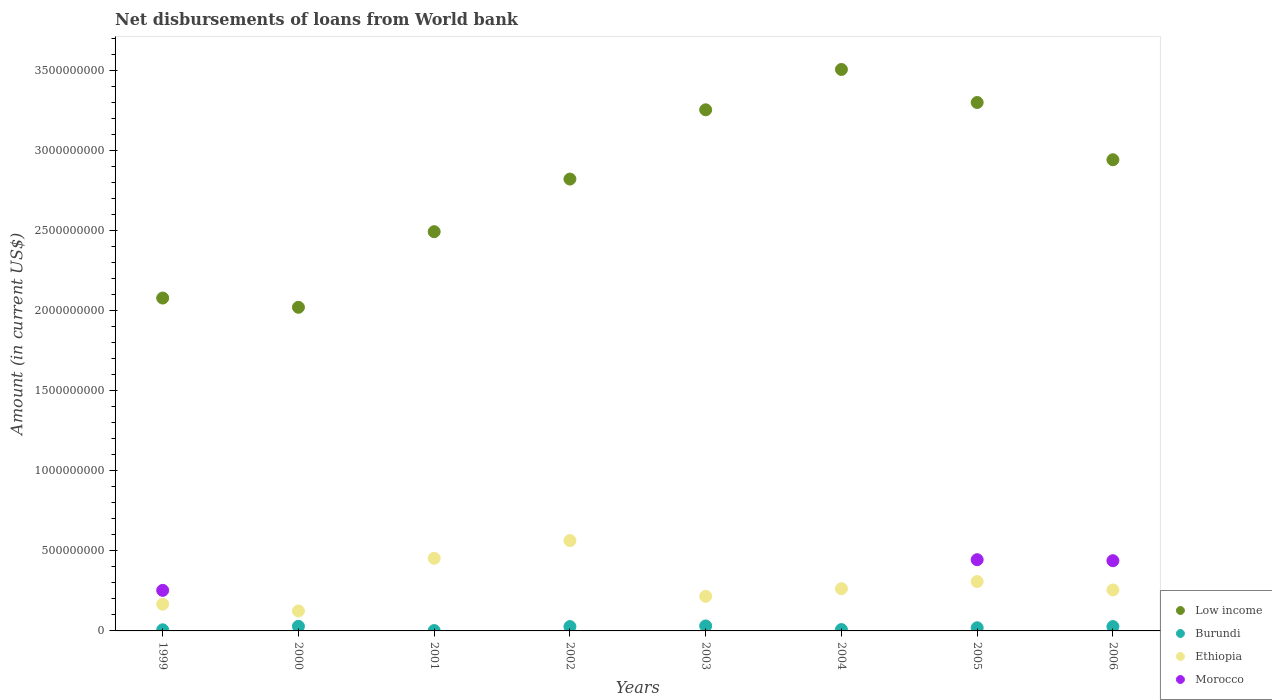How many different coloured dotlines are there?
Keep it short and to the point. 4. What is the amount of loan disbursed from World Bank in Burundi in 2003?
Your response must be concise. 3.12e+07. Across all years, what is the maximum amount of loan disbursed from World Bank in Morocco?
Your answer should be compact. 4.45e+08. Across all years, what is the minimum amount of loan disbursed from World Bank in Burundi?
Keep it short and to the point. 2.28e+06. In which year was the amount of loan disbursed from World Bank in Morocco maximum?
Make the answer very short. 2005. What is the total amount of loan disbursed from World Bank in Morocco in the graph?
Provide a short and direct response. 1.14e+09. What is the difference between the amount of loan disbursed from World Bank in Burundi in 2001 and that in 2004?
Give a very brief answer. -6.18e+06. What is the difference between the amount of loan disbursed from World Bank in Morocco in 2004 and the amount of loan disbursed from World Bank in Low income in 2003?
Provide a short and direct response. -3.26e+09. What is the average amount of loan disbursed from World Bank in Morocco per year?
Keep it short and to the point. 1.42e+08. In the year 2005, what is the difference between the amount of loan disbursed from World Bank in Ethiopia and amount of loan disbursed from World Bank in Low income?
Provide a short and direct response. -2.99e+09. In how many years, is the amount of loan disbursed from World Bank in Ethiopia greater than 1800000000 US$?
Keep it short and to the point. 0. What is the ratio of the amount of loan disbursed from World Bank in Burundi in 2003 to that in 2006?
Your answer should be compact. 1.15. Is the difference between the amount of loan disbursed from World Bank in Ethiopia in 2004 and 2006 greater than the difference between the amount of loan disbursed from World Bank in Low income in 2004 and 2006?
Provide a short and direct response. No. What is the difference between the highest and the second highest amount of loan disbursed from World Bank in Low income?
Provide a short and direct response. 2.06e+08. What is the difference between the highest and the lowest amount of loan disbursed from World Bank in Morocco?
Give a very brief answer. 4.45e+08. In how many years, is the amount of loan disbursed from World Bank in Low income greater than the average amount of loan disbursed from World Bank in Low income taken over all years?
Your answer should be very brief. 5. Is the sum of the amount of loan disbursed from World Bank in Low income in 2002 and 2003 greater than the maximum amount of loan disbursed from World Bank in Morocco across all years?
Offer a very short reply. Yes. Does the amount of loan disbursed from World Bank in Low income monotonically increase over the years?
Provide a succinct answer. No. Is the amount of loan disbursed from World Bank in Morocco strictly greater than the amount of loan disbursed from World Bank in Low income over the years?
Offer a very short reply. No. Is the amount of loan disbursed from World Bank in Morocco strictly less than the amount of loan disbursed from World Bank in Burundi over the years?
Your answer should be very brief. No. How many years are there in the graph?
Your response must be concise. 8. What is the difference between two consecutive major ticks on the Y-axis?
Keep it short and to the point. 5.00e+08. Does the graph contain any zero values?
Your response must be concise. Yes. Does the graph contain grids?
Ensure brevity in your answer.  No. How many legend labels are there?
Your answer should be very brief. 4. What is the title of the graph?
Offer a terse response. Net disbursements of loans from World bank. What is the label or title of the X-axis?
Provide a succinct answer. Years. What is the label or title of the Y-axis?
Make the answer very short. Amount (in current US$). What is the Amount (in current US$) in Low income in 1999?
Give a very brief answer. 2.08e+09. What is the Amount (in current US$) of Burundi in 1999?
Your response must be concise. 6.98e+06. What is the Amount (in current US$) of Ethiopia in 1999?
Offer a very short reply. 1.67e+08. What is the Amount (in current US$) of Morocco in 1999?
Give a very brief answer. 2.53e+08. What is the Amount (in current US$) in Low income in 2000?
Provide a short and direct response. 2.02e+09. What is the Amount (in current US$) of Burundi in 2000?
Give a very brief answer. 2.88e+07. What is the Amount (in current US$) in Ethiopia in 2000?
Your response must be concise. 1.25e+08. What is the Amount (in current US$) in Morocco in 2000?
Your answer should be compact. 0. What is the Amount (in current US$) in Low income in 2001?
Ensure brevity in your answer.  2.50e+09. What is the Amount (in current US$) of Burundi in 2001?
Provide a succinct answer. 2.28e+06. What is the Amount (in current US$) in Ethiopia in 2001?
Offer a terse response. 4.54e+08. What is the Amount (in current US$) in Morocco in 2001?
Give a very brief answer. 0. What is the Amount (in current US$) in Low income in 2002?
Provide a succinct answer. 2.82e+09. What is the Amount (in current US$) in Burundi in 2002?
Your response must be concise. 2.71e+07. What is the Amount (in current US$) in Ethiopia in 2002?
Give a very brief answer. 5.64e+08. What is the Amount (in current US$) in Morocco in 2002?
Your response must be concise. 0. What is the Amount (in current US$) in Low income in 2003?
Your response must be concise. 3.26e+09. What is the Amount (in current US$) of Burundi in 2003?
Your answer should be compact. 3.12e+07. What is the Amount (in current US$) of Ethiopia in 2003?
Provide a succinct answer. 2.16e+08. What is the Amount (in current US$) in Morocco in 2003?
Offer a very short reply. 0. What is the Amount (in current US$) in Low income in 2004?
Offer a very short reply. 3.51e+09. What is the Amount (in current US$) of Burundi in 2004?
Ensure brevity in your answer.  8.47e+06. What is the Amount (in current US$) of Ethiopia in 2004?
Your answer should be very brief. 2.64e+08. What is the Amount (in current US$) of Low income in 2005?
Provide a short and direct response. 3.30e+09. What is the Amount (in current US$) of Burundi in 2005?
Keep it short and to the point. 1.98e+07. What is the Amount (in current US$) in Ethiopia in 2005?
Your answer should be very brief. 3.09e+08. What is the Amount (in current US$) of Morocco in 2005?
Ensure brevity in your answer.  4.45e+08. What is the Amount (in current US$) of Low income in 2006?
Your answer should be very brief. 2.94e+09. What is the Amount (in current US$) in Burundi in 2006?
Your answer should be very brief. 2.72e+07. What is the Amount (in current US$) in Ethiopia in 2006?
Give a very brief answer. 2.56e+08. What is the Amount (in current US$) in Morocco in 2006?
Give a very brief answer. 4.39e+08. Across all years, what is the maximum Amount (in current US$) of Low income?
Make the answer very short. 3.51e+09. Across all years, what is the maximum Amount (in current US$) of Burundi?
Keep it short and to the point. 3.12e+07. Across all years, what is the maximum Amount (in current US$) in Ethiopia?
Offer a terse response. 5.64e+08. Across all years, what is the maximum Amount (in current US$) of Morocco?
Provide a succinct answer. 4.45e+08. Across all years, what is the minimum Amount (in current US$) in Low income?
Offer a very short reply. 2.02e+09. Across all years, what is the minimum Amount (in current US$) in Burundi?
Offer a terse response. 2.28e+06. Across all years, what is the minimum Amount (in current US$) in Ethiopia?
Offer a terse response. 1.25e+08. Across all years, what is the minimum Amount (in current US$) of Morocco?
Give a very brief answer. 0. What is the total Amount (in current US$) of Low income in the graph?
Offer a very short reply. 2.24e+1. What is the total Amount (in current US$) in Burundi in the graph?
Offer a terse response. 1.52e+08. What is the total Amount (in current US$) in Ethiopia in the graph?
Offer a terse response. 2.36e+09. What is the total Amount (in current US$) in Morocco in the graph?
Your response must be concise. 1.14e+09. What is the difference between the Amount (in current US$) in Low income in 1999 and that in 2000?
Offer a very short reply. 5.78e+07. What is the difference between the Amount (in current US$) of Burundi in 1999 and that in 2000?
Offer a very short reply. -2.18e+07. What is the difference between the Amount (in current US$) of Ethiopia in 1999 and that in 2000?
Provide a succinct answer. 4.21e+07. What is the difference between the Amount (in current US$) in Low income in 1999 and that in 2001?
Give a very brief answer. -4.15e+08. What is the difference between the Amount (in current US$) of Burundi in 1999 and that in 2001?
Your answer should be compact. 4.69e+06. What is the difference between the Amount (in current US$) of Ethiopia in 1999 and that in 2001?
Provide a short and direct response. -2.87e+08. What is the difference between the Amount (in current US$) in Low income in 1999 and that in 2002?
Make the answer very short. -7.44e+08. What is the difference between the Amount (in current US$) in Burundi in 1999 and that in 2002?
Offer a terse response. -2.01e+07. What is the difference between the Amount (in current US$) of Ethiopia in 1999 and that in 2002?
Offer a terse response. -3.97e+08. What is the difference between the Amount (in current US$) in Low income in 1999 and that in 2003?
Your answer should be very brief. -1.18e+09. What is the difference between the Amount (in current US$) of Burundi in 1999 and that in 2003?
Your response must be concise. -2.42e+07. What is the difference between the Amount (in current US$) of Ethiopia in 1999 and that in 2003?
Offer a terse response. -4.91e+07. What is the difference between the Amount (in current US$) in Low income in 1999 and that in 2004?
Provide a short and direct response. -1.43e+09. What is the difference between the Amount (in current US$) of Burundi in 1999 and that in 2004?
Provide a succinct answer. -1.49e+06. What is the difference between the Amount (in current US$) in Ethiopia in 1999 and that in 2004?
Your response must be concise. -9.68e+07. What is the difference between the Amount (in current US$) of Low income in 1999 and that in 2005?
Provide a short and direct response. -1.22e+09. What is the difference between the Amount (in current US$) in Burundi in 1999 and that in 2005?
Provide a succinct answer. -1.28e+07. What is the difference between the Amount (in current US$) of Ethiopia in 1999 and that in 2005?
Give a very brief answer. -1.42e+08. What is the difference between the Amount (in current US$) in Morocco in 1999 and that in 2005?
Offer a very short reply. -1.92e+08. What is the difference between the Amount (in current US$) in Low income in 1999 and that in 2006?
Make the answer very short. -8.64e+08. What is the difference between the Amount (in current US$) of Burundi in 1999 and that in 2006?
Offer a terse response. -2.03e+07. What is the difference between the Amount (in current US$) in Ethiopia in 1999 and that in 2006?
Your answer should be compact. -8.91e+07. What is the difference between the Amount (in current US$) in Morocco in 1999 and that in 2006?
Make the answer very short. -1.85e+08. What is the difference between the Amount (in current US$) of Low income in 2000 and that in 2001?
Offer a terse response. -4.73e+08. What is the difference between the Amount (in current US$) in Burundi in 2000 and that in 2001?
Your response must be concise. 2.65e+07. What is the difference between the Amount (in current US$) in Ethiopia in 2000 and that in 2001?
Your answer should be very brief. -3.29e+08. What is the difference between the Amount (in current US$) in Low income in 2000 and that in 2002?
Your answer should be very brief. -8.01e+08. What is the difference between the Amount (in current US$) of Burundi in 2000 and that in 2002?
Give a very brief answer. 1.72e+06. What is the difference between the Amount (in current US$) of Ethiopia in 2000 and that in 2002?
Offer a terse response. -4.40e+08. What is the difference between the Amount (in current US$) of Low income in 2000 and that in 2003?
Your response must be concise. -1.23e+09. What is the difference between the Amount (in current US$) of Burundi in 2000 and that in 2003?
Give a very brief answer. -2.42e+06. What is the difference between the Amount (in current US$) in Ethiopia in 2000 and that in 2003?
Your answer should be compact. -9.12e+07. What is the difference between the Amount (in current US$) of Low income in 2000 and that in 2004?
Your answer should be very brief. -1.49e+09. What is the difference between the Amount (in current US$) in Burundi in 2000 and that in 2004?
Provide a succinct answer. 2.03e+07. What is the difference between the Amount (in current US$) of Ethiopia in 2000 and that in 2004?
Provide a short and direct response. -1.39e+08. What is the difference between the Amount (in current US$) in Low income in 2000 and that in 2005?
Keep it short and to the point. -1.28e+09. What is the difference between the Amount (in current US$) of Burundi in 2000 and that in 2005?
Keep it short and to the point. 9.01e+06. What is the difference between the Amount (in current US$) in Ethiopia in 2000 and that in 2005?
Your answer should be compact. -1.84e+08. What is the difference between the Amount (in current US$) of Low income in 2000 and that in 2006?
Make the answer very short. -9.22e+08. What is the difference between the Amount (in current US$) of Burundi in 2000 and that in 2006?
Ensure brevity in your answer.  1.57e+06. What is the difference between the Amount (in current US$) of Ethiopia in 2000 and that in 2006?
Make the answer very short. -1.31e+08. What is the difference between the Amount (in current US$) of Low income in 2001 and that in 2002?
Your response must be concise. -3.29e+08. What is the difference between the Amount (in current US$) of Burundi in 2001 and that in 2002?
Your answer should be compact. -2.48e+07. What is the difference between the Amount (in current US$) in Ethiopia in 2001 and that in 2002?
Give a very brief answer. -1.11e+08. What is the difference between the Amount (in current US$) of Low income in 2001 and that in 2003?
Make the answer very short. -7.62e+08. What is the difference between the Amount (in current US$) in Burundi in 2001 and that in 2003?
Keep it short and to the point. -2.89e+07. What is the difference between the Amount (in current US$) of Ethiopia in 2001 and that in 2003?
Provide a short and direct response. 2.38e+08. What is the difference between the Amount (in current US$) of Low income in 2001 and that in 2004?
Your answer should be compact. -1.01e+09. What is the difference between the Amount (in current US$) in Burundi in 2001 and that in 2004?
Give a very brief answer. -6.18e+06. What is the difference between the Amount (in current US$) of Ethiopia in 2001 and that in 2004?
Your answer should be compact. 1.90e+08. What is the difference between the Amount (in current US$) of Low income in 2001 and that in 2005?
Keep it short and to the point. -8.07e+08. What is the difference between the Amount (in current US$) of Burundi in 2001 and that in 2005?
Your answer should be very brief. -1.75e+07. What is the difference between the Amount (in current US$) in Ethiopia in 2001 and that in 2005?
Make the answer very short. 1.45e+08. What is the difference between the Amount (in current US$) of Low income in 2001 and that in 2006?
Keep it short and to the point. -4.50e+08. What is the difference between the Amount (in current US$) of Burundi in 2001 and that in 2006?
Ensure brevity in your answer.  -2.49e+07. What is the difference between the Amount (in current US$) of Ethiopia in 2001 and that in 2006?
Keep it short and to the point. 1.98e+08. What is the difference between the Amount (in current US$) in Low income in 2002 and that in 2003?
Your answer should be compact. -4.33e+08. What is the difference between the Amount (in current US$) in Burundi in 2002 and that in 2003?
Ensure brevity in your answer.  -4.14e+06. What is the difference between the Amount (in current US$) in Ethiopia in 2002 and that in 2003?
Provide a short and direct response. 3.48e+08. What is the difference between the Amount (in current US$) in Low income in 2002 and that in 2004?
Keep it short and to the point. -6.85e+08. What is the difference between the Amount (in current US$) in Burundi in 2002 and that in 2004?
Make the answer very short. 1.86e+07. What is the difference between the Amount (in current US$) of Ethiopia in 2002 and that in 2004?
Give a very brief answer. 3.01e+08. What is the difference between the Amount (in current US$) in Low income in 2002 and that in 2005?
Give a very brief answer. -4.79e+08. What is the difference between the Amount (in current US$) in Burundi in 2002 and that in 2005?
Your answer should be compact. 7.29e+06. What is the difference between the Amount (in current US$) in Ethiopia in 2002 and that in 2005?
Offer a terse response. 2.56e+08. What is the difference between the Amount (in current US$) of Low income in 2002 and that in 2006?
Keep it short and to the point. -1.21e+08. What is the difference between the Amount (in current US$) in Burundi in 2002 and that in 2006?
Provide a short and direct response. -1.52e+05. What is the difference between the Amount (in current US$) of Ethiopia in 2002 and that in 2006?
Offer a terse response. 3.08e+08. What is the difference between the Amount (in current US$) of Low income in 2003 and that in 2004?
Your response must be concise. -2.52e+08. What is the difference between the Amount (in current US$) in Burundi in 2003 and that in 2004?
Your response must be concise. 2.28e+07. What is the difference between the Amount (in current US$) of Ethiopia in 2003 and that in 2004?
Your answer should be very brief. -4.77e+07. What is the difference between the Amount (in current US$) in Low income in 2003 and that in 2005?
Your response must be concise. -4.56e+07. What is the difference between the Amount (in current US$) in Burundi in 2003 and that in 2005?
Provide a succinct answer. 1.14e+07. What is the difference between the Amount (in current US$) of Ethiopia in 2003 and that in 2005?
Your response must be concise. -9.26e+07. What is the difference between the Amount (in current US$) in Low income in 2003 and that in 2006?
Your answer should be very brief. 3.12e+08. What is the difference between the Amount (in current US$) of Burundi in 2003 and that in 2006?
Offer a terse response. 3.99e+06. What is the difference between the Amount (in current US$) of Ethiopia in 2003 and that in 2006?
Offer a terse response. -4.00e+07. What is the difference between the Amount (in current US$) in Low income in 2004 and that in 2005?
Give a very brief answer. 2.06e+08. What is the difference between the Amount (in current US$) in Burundi in 2004 and that in 2005?
Your answer should be compact. -1.13e+07. What is the difference between the Amount (in current US$) of Ethiopia in 2004 and that in 2005?
Your answer should be very brief. -4.49e+07. What is the difference between the Amount (in current US$) of Low income in 2004 and that in 2006?
Offer a terse response. 5.64e+08. What is the difference between the Amount (in current US$) in Burundi in 2004 and that in 2006?
Provide a succinct answer. -1.88e+07. What is the difference between the Amount (in current US$) in Ethiopia in 2004 and that in 2006?
Ensure brevity in your answer.  7.74e+06. What is the difference between the Amount (in current US$) of Low income in 2005 and that in 2006?
Give a very brief answer. 3.58e+08. What is the difference between the Amount (in current US$) of Burundi in 2005 and that in 2006?
Ensure brevity in your answer.  -7.45e+06. What is the difference between the Amount (in current US$) of Ethiopia in 2005 and that in 2006?
Provide a succinct answer. 5.26e+07. What is the difference between the Amount (in current US$) in Morocco in 2005 and that in 2006?
Make the answer very short. 6.27e+06. What is the difference between the Amount (in current US$) of Low income in 1999 and the Amount (in current US$) of Burundi in 2000?
Provide a succinct answer. 2.05e+09. What is the difference between the Amount (in current US$) in Low income in 1999 and the Amount (in current US$) in Ethiopia in 2000?
Give a very brief answer. 1.96e+09. What is the difference between the Amount (in current US$) of Burundi in 1999 and the Amount (in current US$) of Ethiopia in 2000?
Your answer should be compact. -1.18e+08. What is the difference between the Amount (in current US$) of Low income in 1999 and the Amount (in current US$) of Burundi in 2001?
Offer a terse response. 2.08e+09. What is the difference between the Amount (in current US$) in Low income in 1999 and the Amount (in current US$) in Ethiopia in 2001?
Keep it short and to the point. 1.63e+09. What is the difference between the Amount (in current US$) in Burundi in 1999 and the Amount (in current US$) in Ethiopia in 2001?
Provide a succinct answer. -4.47e+08. What is the difference between the Amount (in current US$) in Low income in 1999 and the Amount (in current US$) in Burundi in 2002?
Provide a succinct answer. 2.05e+09. What is the difference between the Amount (in current US$) of Low income in 1999 and the Amount (in current US$) of Ethiopia in 2002?
Ensure brevity in your answer.  1.52e+09. What is the difference between the Amount (in current US$) in Burundi in 1999 and the Amount (in current US$) in Ethiopia in 2002?
Provide a short and direct response. -5.58e+08. What is the difference between the Amount (in current US$) in Low income in 1999 and the Amount (in current US$) in Burundi in 2003?
Ensure brevity in your answer.  2.05e+09. What is the difference between the Amount (in current US$) of Low income in 1999 and the Amount (in current US$) of Ethiopia in 2003?
Your answer should be very brief. 1.86e+09. What is the difference between the Amount (in current US$) in Burundi in 1999 and the Amount (in current US$) in Ethiopia in 2003?
Make the answer very short. -2.09e+08. What is the difference between the Amount (in current US$) in Low income in 1999 and the Amount (in current US$) in Burundi in 2004?
Ensure brevity in your answer.  2.07e+09. What is the difference between the Amount (in current US$) in Low income in 1999 and the Amount (in current US$) in Ethiopia in 2004?
Offer a very short reply. 1.82e+09. What is the difference between the Amount (in current US$) in Burundi in 1999 and the Amount (in current US$) in Ethiopia in 2004?
Provide a short and direct response. -2.57e+08. What is the difference between the Amount (in current US$) of Low income in 1999 and the Amount (in current US$) of Burundi in 2005?
Give a very brief answer. 2.06e+09. What is the difference between the Amount (in current US$) of Low income in 1999 and the Amount (in current US$) of Ethiopia in 2005?
Give a very brief answer. 1.77e+09. What is the difference between the Amount (in current US$) in Low income in 1999 and the Amount (in current US$) in Morocco in 2005?
Offer a very short reply. 1.64e+09. What is the difference between the Amount (in current US$) of Burundi in 1999 and the Amount (in current US$) of Ethiopia in 2005?
Give a very brief answer. -3.02e+08. What is the difference between the Amount (in current US$) in Burundi in 1999 and the Amount (in current US$) in Morocco in 2005?
Your answer should be compact. -4.38e+08. What is the difference between the Amount (in current US$) in Ethiopia in 1999 and the Amount (in current US$) in Morocco in 2005?
Keep it short and to the point. -2.78e+08. What is the difference between the Amount (in current US$) in Low income in 1999 and the Amount (in current US$) in Burundi in 2006?
Keep it short and to the point. 2.05e+09. What is the difference between the Amount (in current US$) in Low income in 1999 and the Amount (in current US$) in Ethiopia in 2006?
Provide a succinct answer. 1.82e+09. What is the difference between the Amount (in current US$) in Low income in 1999 and the Amount (in current US$) in Morocco in 2006?
Make the answer very short. 1.64e+09. What is the difference between the Amount (in current US$) of Burundi in 1999 and the Amount (in current US$) of Ethiopia in 2006?
Provide a succinct answer. -2.49e+08. What is the difference between the Amount (in current US$) of Burundi in 1999 and the Amount (in current US$) of Morocco in 2006?
Give a very brief answer. -4.32e+08. What is the difference between the Amount (in current US$) in Ethiopia in 1999 and the Amount (in current US$) in Morocco in 2006?
Your answer should be very brief. -2.72e+08. What is the difference between the Amount (in current US$) of Low income in 2000 and the Amount (in current US$) of Burundi in 2001?
Provide a succinct answer. 2.02e+09. What is the difference between the Amount (in current US$) in Low income in 2000 and the Amount (in current US$) in Ethiopia in 2001?
Your answer should be compact. 1.57e+09. What is the difference between the Amount (in current US$) in Burundi in 2000 and the Amount (in current US$) in Ethiopia in 2001?
Your answer should be compact. -4.25e+08. What is the difference between the Amount (in current US$) in Low income in 2000 and the Amount (in current US$) in Burundi in 2002?
Offer a very short reply. 2.00e+09. What is the difference between the Amount (in current US$) of Low income in 2000 and the Amount (in current US$) of Ethiopia in 2002?
Give a very brief answer. 1.46e+09. What is the difference between the Amount (in current US$) in Burundi in 2000 and the Amount (in current US$) in Ethiopia in 2002?
Give a very brief answer. -5.36e+08. What is the difference between the Amount (in current US$) in Low income in 2000 and the Amount (in current US$) in Burundi in 2003?
Your answer should be compact. 1.99e+09. What is the difference between the Amount (in current US$) of Low income in 2000 and the Amount (in current US$) of Ethiopia in 2003?
Offer a very short reply. 1.81e+09. What is the difference between the Amount (in current US$) of Burundi in 2000 and the Amount (in current US$) of Ethiopia in 2003?
Make the answer very short. -1.87e+08. What is the difference between the Amount (in current US$) of Low income in 2000 and the Amount (in current US$) of Burundi in 2004?
Offer a very short reply. 2.01e+09. What is the difference between the Amount (in current US$) of Low income in 2000 and the Amount (in current US$) of Ethiopia in 2004?
Make the answer very short. 1.76e+09. What is the difference between the Amount (in current US$) in Burundi in 2000 and the Amount (in current US$) in Ethiopia in 2004?
Ensure brevity in your answer.  -2.35e+08. What is the difference between the Amount (in current US$) in Low income in 2000 and the Amount (in current US$) in Burundi in 2005?
Your answer should be compact. 2.00e+09. What is the difference between the Amount (in current US$) in Low income in 2000 and the Amount (in current US$) in Ethiopia in 2005?
Offer a very short reply. 1.71e+09. What is the difference between the Amount (in current US$) in Low income in 2000 and the Amount (in current US$) in Morocco in 2005?
Give a very brief answer. 1.58e+09. What is the difference between the Amount (in current US$) of Burundi in 2000 and the Amount (in current US$) of Ethiopia in 2005?
Give a very brief answer. -2.80e+08. What is the difference between the Amount (in current US$) of Burundi in 2000 and the Amount (in current US$) of Morocco in 2005?
Ensure brevity in your answer.  -4.16e+08. What is the difference between the Amount (in current US$) in Ethiopia in 2000 and the Amount (in current US$) in Morocco in 2005?
Your answer should be compact. -3.20e+08. What is the difference between the Amount (in current US$) of Low income in 2000 and the Amount (in current US$) of Burundi in 2006?
Keep it short and to the point. 2.00e+09. What is the difference between the Amount (in current US$) of Low income in 2000 and the Amount (in current US$) of Ethiopia in 2006?
Your response must be concise. 1.77e+09. What is the difference between the Amount (in current US$) in Low income in 2000 and the Amount (in current US$) in Morocco in 2006?
Your answer should be very brief. 1.58e+09. What is the difference between the Amount (in current US$) of Burundi in 2000 and the Amount (in current US$) of Ethiopia in 2006?
Provide a succinct answer. -2.27e+08. What is the difference between the Amount (in current US$) of Burundi in 2000 and the Amount (in current US$) of Morocco in 2006?
Offer a terse response. -4.10e+08. What is the difference between the Amount (in current US$) of Ethiopia in 2000 and the Amount (in current US$) of Morocco in 2006?
Give a very brief answer. -3.14e+08. What is the difference between the Amount (in current US$) in Low income in 2001 and the Amount (in current US$) in Burundi in 2002?
Provide a succinct answer. 2.47e+09. What is the difference between the Amount (in current US$) in Low income in 2001 and the Amount (in current US$) in Ethiopia in 2002?
Keep it short and to the point. 1.93e+09. What is the difference between the Amount (in current US$) of Burundi in 2001 and the Amount (in current US$) of Ethiopia in 2002?
Provide a short and direct response. -5.62e+08. What is the difference between the Amount (in current US$) of Low income in 2001 and the Amount (in current US$) of Burundi in 2003?
Provide a succinct answer. 2.46e+09. What is the difference between the Amount (in current US$) of Low income in 2001 and the Amount (in current US$) of Ethiopia in 2003?
Ensure brevity in your answer.  2.28e+09. What is the difference between the Amount (in current US$) of Burundi in 2001 and the Amount (in current US$) of Ethiopia in 2003?
Offer a terse response. -2.14e+08. What is the difference between the Amount (in current US$) in Low income in 2001 and the Amount (in current US$) in Burundi in 2004?
Your answer should be compact. 2.49e+09. What is the difference between the Amount (in current US$) of Low income in 2001 and the Amount (in current US$) of Ethiopia in 2004?
Provide a succinct answer. 2.23e+09. What is the difference between the Amount (in current US$) in Burundi in 2001 and the Amount (in current US$) in Ethiopia in 2004?
Offer a very short reply. -2.62e+08. What is the difference between the Amount (in current US$) in Low income in 2001 and the Amount (in current US$) in Burundi in 2005?
Your answer should be very brief. 2.48e+09. What is the difference between the Amount (in current US$) in Low income in 2001 and the Amount (in current US$) in Ethiopia in 2005?
Make the answer very short. 2.19e+09. What is the difference between the Amount (in current US$) in Low income in 2001 and the Amount (in current US$) in Morocco in 2005?
Ensure brevity in your answer.  2.05e+09. What is the difference between the Amount (in current US$) of Burundi in 2001 and the Amount (in current US$) of Ethiopia in 2005?
Your answer should be compact. -3.06e+08. What is the difference between the Amount (in current US$) in Burundi in 2001 and the Amount (in current US$) in Morocco in 2005?
Offer a very short reply. -4.43e+08. What is the difference between the Amount (in current US$) in Ethiopia in 2001 and the Amount (in current US$) in Morocco in 2005?
Your answer should be very brief. 8.73e+06. What is the difference between the Amount (in current US$) of Low income in 2001 and the Amount (in current US$) of Burundi in 2006?
Offer a very short reply. 2.47e+09. What is the difference between the Amount (in current US$) of Low income in 2001 and the Amount (in current US$) of Ethiopia in 2006?
Your answer should be compact. 2.24e+09. What is the difference between the Amount (in current US$) in Low income in 2001 and the Amount (in current US$) in Morocco in 2006?
Offer a very short reply. 2.06e+09. What is the difference between the Amount (in current US$) of Burundi in 2001 and the Amount (in current US$) of Ethiopia in 2006?
Provide a short and direct response. -2.54e+08. What is the difference between the Amount (in current US$) in Burundi in 2001 and the Amount (in current US$) in Morocco in 2006?
Offer a terse response. -4.37e+08. What is the difference between the Amount (in current US$) in Ethiopia in 2001 and the Amount (in current US$) in Morocco in 2006?
Offer a terse response. 1.50e+07. What is the difference between the Amount (in current US$) in Low income in 2002 and the Amount (in current US$) in Burundi in 2003?
Your response must be concise. 2.79e+09. What is the difference between the Amount (in current US$) in Low income in 2002 and the Amount (in current US$) in Ethiopia in 2003?
Provide a short and direct response. 2.61e+09. What is the difference between the Amount (in current US$) of Burundi in 2002 and the Amount (in current US$) of Ethiopia in 2003?
Give a very brief answer. -1.89e+08. What is the difference between the Amount (in current US$) in Low income in 2002 and the Amount (in current US$) in Burundi in 2004?
Provide a succinct answer. 2.82e+09. What is the difference between the Amount (in current US$) of Low income in 2002 and the Amount (in current US$) of Ethiopia in 2004?
Offer a very short reply. 2.56e+09. What is the difference between the Amount (in current US$) in Burundi in 2002 and the Amount (in current US$) in Ethiopia in 2004?
Provide a succinct answer. -2.37e+08. What is the difference between the Amount (in current US$) of Low income in 2002 and the Amount (in current US$) of Burundi in 2005?
Keep it short and to the point. 2.80e+09. What is the difference between the Amount (in current US$) in Low income in 2002 and the Amount (in current US$) in Ethiopia in 2005?
Provide a succinct answer. 2.52e+09. What is the difference between the Amount (in current US$) in Low income in 2002 and the Amount (in current US$) in Morocco in 2005?
Your answer should be very brief. 2.38e+09. What is the difference between the Amount (in current US$) of Burundi in 2002 and the Amount (in current US$) of Ethiopia in 2005?
Give a very brief answer. -2.82e+08. What is the difference between the Amount (in current US$) in Burundi in 2002 and the Amount (in current US$) in Morocco in 2005?
Offer a very short reply. -4.18e+08. What is the difference between the Amount (in current US$) of Ethiopia in 2002 and the Amount (in current US$) of Morocco in 2005?
Your answer should be very brief. 1.19e+08. What is the difference between the Amount (in current US$) of Low income in 2002 and the Amount (in current US$) of Burundi in 2006?
Keep it short and to the point. 2.80e+09. What is the difference between the Amount (in current US$) in Low income in 2002 and the Amount (in current US$) in Ethiopia in 2006?
Keep it short and to the point. 2.57e+09. What is the difference between the Amount (in current US$) of Low income in 2002 and the Amount (in current US$) of Morocco in 2006?
Offer a very short reply. 2.39e+09. What is the difference between the Amount (in current US$) in Burundi in 2002 and the Amount (in current US$) in Ethiopia in 2006?
Ensure brevity in your answer.  -2.29e+08. What is the difference between the Amount (in current US$) of Burundi in 2002 and the Amount (in current US$) of Morocco in 2006?
Keep it short and to the point. -4.12e+08. What is the difference between the Amount (in current US$) in Ethiopia in 2002 and the Amount (in current US$) in Morocco in 2006?
Your response must be concise. 1.26e+08. What is the difference between the Amount (in current US$) in Low income in 2003 and the Amount (in current US$) in Burundi in 2004?
Ensure brevity in your answer.  3.25e+09. What is the difference between the Amount (in current US$) in Low income in 2003 and the Amount (in current US$) in Ethiopia in 2004?
Provide a succinct answer. 2.99e+09. What is the difference between the Amount (in current US$) of Burundi in 2003 and the Amount (in current US$) of Ethiopia in 2004?
Provide a succinct answer. -2.33e+08. What is the difference between the Amount (in current US$) in Low income in 2003 and the Amount (in current US$) in Burundi in 2005?
Your response must be concise. 3.24e+09. What is the difference between the Amount (in current US$) in Low income in 2003 and the Amount (in current US$) in Ethiopia in 2005?
Your answer should be compact. 2.95e+09. What is the difference between the Amount (in current US$) in Low income in 2003 and the Amount (in current US$) in Morocco in 2005?
Offer a terse response. 2.81e+09. What is the difference between the Amount (in current US$) of Burundi in 2003 and the Amount (in current US$) of Ethiopia in 2005?
Provide a succinct answer. -2.78e+08. What is the difference between the Amount (in current US$) of Burundi in 2003 and the Amount (in current US$) of Morocco in 2005?
Your answer should be very brief. -4.14e+08. What is the difference between the Amount (in current US$) in Ethiopia in 2003 and the Amount (in current US$) in Morocco in 2005?
Your answer should be very brief. -2.29e+08. What is the difference between the Amount (in current US$) in Low income in 2003 and the Amount (in current US$) in Burundi in 2006?
Offer a terse response. 3.23e+09. What is the difference between the Amount (in current US$) in Low income in 2003 and the Amount (in current US$) in Ethiopia in 2006?
Your response must be concise. 3.00e+09. What is the difference between the Amount (in current US$) in Low income in 2003 and the Amount (in current US$) in Morocco in 2006?
Your answer should be compact. 2.82e+09. What is the difference between the Amount (in current US$) in Burundi in 2003 and the Amount (in current US$) in Ethiopia in 2006?
Provide a short and direct response. -2.25e+08. What is the difference between the Amount (in current US$) in Burundi in 2003 and the Amount (in current US$) in Morocco in 2006?
Offer a very short reply. -4.08e+08. What is the difference between the Amount (in current US$) of Ethiopia in 2003 and the Amount (in current US$) of Morocco in 2006?
Provide a succinct answer. -2.23e+08. What is the difference between the Amount (in current US$) of Low income in 2004 and the Amount (in current US$) of Burundi in 2005?
Make the answer very short. 3.49e+09. What is the difference between the Amount (in current US$) in Low income in 2004 and the Amount (in current US$) in Ethiopia in 2005?
Give a very brief answer. 3.20e+09. What is the difference between the Amount (in current US$) in Low income in 2004 and the Amount (in current US$) in Morocco in 2005?
Your response must be concise. 3.06e+09. What is the difference between the Amount (in current US$) of Burundi in 2004 and the Amount (in current US$) of Ethiopia in 2005?
Offer a very short reply. -3.00e+08. What is the difference between the Amount (in current US$) in Burundi in 2004 and the Amount (in current US$) in Morocco in 2005?
Make the answer very short. -4.37e+08. What is the difference between the Amount (in current US$) in Ethiopia in 2004 and the Amount (in current US$) in Morocco in 2005?
Keep it short and to the point. -1.81e+08. What is the difference between the Amount (in current US$) in Low income in 2004 and the Amount (in current US$) in Burundi in 2006?
Give a very brief answer. 3.48e+09. What is the difference between the Amount (in current US$) in Low income in 2004 and the Amount (in current US$) in Ethiopia in 2006?
Your answer should be compact. 3.25e+09. What is the difference between the Amount (in current US$) in Low income in 2004 and the Amount (in current US$) in Morocco in 2006?
Ensure brevity in your answer.  3.07e+09. What is the difference between the Amount (in current US$) in Burundi in 2004 and the Amount (in current US$) in Ethiopia in 2006?
Your response must be concise. -2.48e+08. What is the difference between the Amount (in current US$) in Burundi in 2004 and the Amount (in current US$) in Morocco in 2006?
Provide a short and direct response. -4.30e+08. What is the difference between the Amount (in current US$) of Ethiopia in 2004 and the Amount (in current US$) of Morocco in 2006?
Keep it short and to the point. -1.75e+08. What is the difference between the Amount (in current US$) in Low income in 2005 and the Amount (in current US$) in Burundi in 2006?
Your answer should be very brief. 3.28e+09. What is the difference between the Amount (in current US$) of Low income in 2005 and the Amount (in current US$) of Ethiopia in 2006?
Keep it short and to the point. 3.05e+09. What is the difference between the Amount (in current US$) of Low income in 2005 and the Amount (in current US$) of Morocco in 2006?
Provide a short and direct response. 2.86e+09. What is the difference between the Amount (in current US$) in Burundi in 2005 and the Amount (in current US$) in Ethiopia in 2006?
Offer a terse response. -2.36e+08. What is the difference between the Amount (in current US$) of Burundi in 2005 and the Amount (in current US$) of Morocco in 2006?
Your response must be concise. -4.19e+08. What is the difference between the Amount (in current US$) in Ethiopia in 2005 and the Amount (in current US$) in Morocco in 2006?
Offer a terse response. -1.30e+08. What is the average Amount (in current US$) of Low income per year?
Make the answer very short. 2.80e+09. What is the average Amount (in current US$) of Burundi per year?
Offer a very short reply. 1.90e+07. What is the average Amount (in current US$) in Ethiopia per year?
Offer a terse response. 2.94e+08. What is the average Amount (in current US$) in Morocco per year?
Make the answer very short. 1.42e+08. In the year 1999, what is the difference between the Amount (in current US$) in Low income and Amount (in current US$) in Burundi?
Offer a terse response. 2.07e+09. In the year 1999, what is the difference between the Amount (in current US$) in Low income and Amount (in current US$) in Ethiopia?
Offer a terse response. 1.91e+09. In the year 1999, what is the difference between the Amount (in current US$) of Low income and Amount (in current US$) of Morocco?
Make the answer very short. 1.83e+09. In the year 1999, what is the difference between the Amount (in current US$) in Burundi and Amount (in current US$) in Ethiopia?
Your answer should be very brief. -1.60e+08. In the year 1999, what is the difference between the Amount (in current US$) in Burundi and Amount (in current US$) in Morocco?
Offer a very short reply. -2.46e+08. In the year 1999, what is the difference between the Amount (in current US$) in Ethiopia and Amount (in current US$) in Morocco?
Your answer should be very brief. -8.64e+07. In the year 2000, what is the difference between the Amount (in current US$) of Low income and Amount (in current US$) of Burundi?
Offer a terse response. 1.99e+09. In the year 2000, what is the difference between the Amount (in current US$) in Low income and Amount (in current US$) in Ethiopia?
Give a very brief answer. 1.90e+09. In the year 2000, what is the difference between the Amount (in current US$) in Burundi and Amount (in current US$) in Ethiopia?
Make the answer very short. -9.61e+07. In the year 2001, what is the difference between the Amount (in current US$) in Low income and Amount (in current US$) in Burundi?
Provide a short and direct response. 2.49e+09. In the year 2001, what is the difference between the Amount (in current US$) of Low income and Amount (in current US$) of Ethiopia?
Offer a very short reply. 2.04e+09. In the year 2001, what is the difference between the Amount (in current US$) of Burundi and Amount (in current US$) of Ethiopia?
Keep it short and to the point. -4.52e+08. In the year 2002, what is the difference between the Amount (in current US$) in Low income and Amount (in current US$) in Burundi?
Your response must be concise. 2.80e+09. In the year 2002, what is the difference between the Amount (in current US$) of Low income and Amount (in current US$) of Ethiopia?
Give a very brief answer. 2.26e+09. In the year 2002, what is the difference between the Amount (in current US$) of Burundi and Amount (in current US$) of Ethiopia?
Provide a succinct answer. -5.37e+08. In the year 2003, what is the difference between the Amount (in current US$) in Low income and Amount (in current US$) in Burundi?
Offer a terse response. 3.23e+09. In the year 2003, what is the difference between the Amount (in current US$) of Low income and Amount (in current US$) of Ethiopia?
Give a very brief answer. 3.04e+09. In the year 2003, what is the difference between the Amount (in current US$) in Burundi and Amount (in current US$) in Ethiopia?
Offer a very short reply. -1.85e+08. In the year 2004, what is the difference between the Amount (in current US$) of Low income and Amount (in current US$) of Burundi?
Make the answer very short. 3.50e+09. In the year 2004, what is the difference between the Amount (in current US$) in Low income and Amount (in current US$) in Ethiopia?
Your answer should be compact. 3.25e+09. In the year 2004, what is the difference between the Amount (in current US$) of Burundi and Amount (in current US$) of Ethiopia?
Offer a very short reply. -2.55e+08. In the year 2005, what is the difference between the Amount (in current US$) in Low income and Amount (in current US$) in Burundi?
Ensure brevity in your answer.  3.28e+09. In the year 2005, what is the difference between the Amount (in current US$) in Low income and Amount (in current US$) in Ethiopia?
Your response must be concise. 2.99e+09. In the year 2005, what is the difference between the Amount (in current US$) of Low income and Amount (in current US$) of Morocco?
Ensure brevity in your answer.  2.86e+09. In the year 2005, what is the difference between the Amount (in current US$) of Burundi and Amount (in current US$) of Ethiopia?
Make the answer very short. -2.89e+08. In the year 2005, what is the difference between the Amount (in current US$) of Burundi and Amount (in current US$) of Morocco?
Offer a very short reply. -4.25e+08. In the year 2005, what is the difference between the Amount (in current US$) of Ethiopia and Amount (in current US$) of Morocco?
Ensure brevity in your answer.  -1.36e+08. In the year 2006, what is the difference between the Amount (in current US$) of Low income and Amount (in current US$) of Burundi?
Give a very brief answer. 2.92e+09. In the year 2006, what is the difference between the Amount (in current US$) of Low income and Amount (in current US$) of Ethiopia?
Make the answer very short. 2.69e+09. In the year 2006, what is the difference between the Amount (in current US$) in Low income and Amount (in current US$) in Morocco?
Your answer should be very brief. 2.51e+09. In the year 2006, what is the difference between the Amount (in current US$) in Burundi and Amount (in current US$) in Ethiopia?
Provide a short and direct response. -2.29e+08. In the year 2006, what is the difference between the Amount (in current US$) of Burundi and Amount (in current US$) of Morocco?
Your response must be concise. -4.12e+08. In the year 2006, what is the difference between the Amount (in current US$) of Ethiopia and Amount (in current US$) of Morocco?
Your response must be concise. -1.83e+08. What is the ratio of the Amount (in current US$) of Low income in 1999 to that in 2000?
Ensure brevity in your answer.  1.03. What is the ratio of the Amount (in current US$) of Burundi in 1999 to that in 2000?
Ensure brevity in your answer.  0.24. What is the ratio of the Amount (in current US$) of Ethiopia in 1999 to that in 2000?
Provide a short and direct response. 1.34. What is the ratio of the Amount (in current US$) in Low income in 1999 to that in 2001?
Make the answer very short. 0.83. What is the ratio of the Amount (in current US$) of Burundi in 1999 to that in 2001?
Give a very brief answer. 3.05. What is the ratio of the Amount (in current US$) in Ethiopia in 1999 to that in 2001?
Give a very brief answer. 0.37. What is the ratio of the Amount (in current US$) of Low income in 1999 to that in 2002?
Your answer should be very brief. 0.74. What is the ratio of the Amount (in current US$) in Burundi in 1999 to that in 2002?
Your answer should be compact. 0.26. What is the ratio of the Amount (in current US$) of Ethiopia in 1999 to that in 2002?
Provide a succinct answer. 0.3. What is the ratio of the Amount (in current US$) of Low income in 1999 to that in 2003?
Offer a terse response. 0.64. What is the ratio of the Amount (in current US$) in Burundi in 1999 to that in 2003?
Your answer should be very brief. 0.22. What is the ratio of the Amount (in current US$) in Ethiopia in 1999 to that in 2003?
Offer a terse response. 0.77. What is the ratio of the Amount (in current US$) in Low income in 1999 to that in 2004?
Offer a terse response. 0.59. What is the ratio of the Amount (in current US$) of Burundi in 1999 to that in 2004?
Make the answer very short. 0.82. What is the ratio of the Amount (in current US$) in Ethiopia in 1999 to that in 2004?
Provide a short and direct response. 0.63. What is the ratio of the Amount (in current US$) in Low income in 1999 to that in 2005?
Offer a very short reply. 0.63. What is the ratio of the Amount (in current US$) of Burundi in 1999 to that in 2005?
Your response must be concise. 0.35. What is the ratio of the Amount (in current US$) of Ethiopia in 1999 to that in 2005?
Provide a short and direct response. 0.54. What is the ratio of the Amount (in current US$) of Morocco in 1999 to that in 2005?
Your response must be concise. 0.57. What is the ratio of the Amount (in current US$) in Low income in 1999 to that in 2006?
Offer a terse response. 0.71. What is the ratio of the Amount (in current US$) in Burundi in 1999 to that in 2006?
Your answer should be very brief. 0.26. What is the ratio of the Amount (in current US$) of Ethiopia in 1999 to that in 2006?
Ensure brevity in your answer.  0.65. What is the ratio of the Amount (in current US$) of Morocco in 1999 to that in 2006?
Ensure brevity in your answer.  0.58. What is the ratio of the Amount (in current US$) of Low income in 2000 to that in 2001?
Keep it short and to the point. 0.81. What is the ratio of the Amount (in current US$) in Burundi in 2000 to that in 2001?
Ensure brevity in your answer.  12.6. What is the ratio of the Amount (in current US$) of Ethiopia in 2000 to that in 2001?
Ensure brevity in your answer.  0.28. What is the ratio of the Amount (in current US$) of Low income in 2000 to that in 2002?
Ensure brevity in your answer.  0.72. What is the ratio of the Amount (in current US$) of Burundi in 2000 to that in 2002?
Provide a succinct answer. 1.06. What is the ratio of the Amount (in current US$) of Ethiopia in 2000 to that in 2002?
Provide a short and direct response. 0.22. What is the ratio of the Amount (in current US$) in Low income in 2000 to that in 2003?
Your answer should be very brief. 0.62. What is the ratio of the Amount (in current US$) in Burundi in 2000 to that in 2003?
Ensure brevity in your answer.  0.92. What is the ratio of the Amount (in current US$) of Ethiopia in 2000 to that in 2003?
Keep it short and to the point. 0.58. What is the ratio of the Amount (in current US$) of Low income in 2000 to that in 2004?
Offer a very short reply. 0.58. What is the ratio of the Amount (in current US$) in Burundi in 2000 to that in 2004?
Your response must be concise. 3.4. What is the ratio of the Amount (in current US$) in Ethiopia in 2000 to that in 2004?
Provide a succinct answer. 0.47. What is the ratio of the Amount (in current US$) in Low income in 2000 to that in 2005?
Provide a succinct answer. 0.61. What is the ratio of the Amount (in current US$) in Burundi in 2000 to that in 2005?
Provide a short and direct response. 1.46. What is the ratio of the Amount (in current US$) in Ethiopia in 2000 to that in 2005?
Offer a very short reply. 0.4. What is the ratio of the Amount (in current US$) in Low income in 2000 to that in 2006?
Offer a terse response. 0.69. What is the ratio of the Amount (in current US$) of Burundi in 2000 to that in 2006?
Your response must be concise. 1.06. What is the ratio of the Amount (in current US$) of Ethiopia in 2000 to that in 2006?
Offer a terse response. 0.49. What is the ratio of the Amount (in current US$) of Low income in 2001 to that in 2002?
Provide a succinct answer. 0.88. What is the ratio of the Amount (in current US$) in Burundi in 2001 to that in 2002?
Your answer should be compact. 0.08. What is the ratio of the Amount (in current US$) of Ethiopia in 2001 to that in 2002?
Offer a terse response. 0.8. What is the ratio of the Amount (in current US$) in Low income in 2001 to that in 2003?
Offer a terse response. 0.77. What is the ratio of the Amount (in current US$) in Burundi in 2001 to that in 2003?
Give a very brief answer. 0.07. What is the ratio of the Amount (in current US$) in Ethiopia in 2001 to that in 2003?
Offer a very short reply. 2.1. What is the ratio of the Amount (in current US$) in Low income in 2001 to that in 2004?
Offer a terse response. 0.71. What is the ratio of the Amount (in current US$) of Burundi in 2001 to that in 2004?
Offer a terse response. 0.27. What is the ratio of the Amount (in current US$) in Ethiopia in 2001 to that in 2004?
Provide a short and direct response. 1.72. What is the ratio of the Amount (in current US$) of Low income in 2001 to that in 2005?
Offer a terse response. 0.76. What is the ratio of the Amount (in current US$) in Burundi in 2001 to that in 2005?
Your answer should be compact. 0.12. What is the ratio of the Amount (in current US$) of Ethiopia in 2001 to that in 2005?
Provide a short and direct response. 1.47. What is the ratio of the Amount (in current US$) in Low income in 2001 to that in 2006?
Offer a very short reply. 0.85. What is the ratio of the Amount (in current US$) of Burundi in 2001 to that in 2006?
Your answer should be very brief. 0.08. What is the ratio of the Amount (in current US$) of Ethiopia in 2001 to that in 2006?
Provide a succinct answer. 1.77. What is the ratio of the Amount (in current US$) of Low income in 2002 to that in 2003?
Your response must be concise. 0.87. What is the ratio of the Amount (in current US$) of Burundi in 2002 to that in 2003?
Ensure brevity in your answer.  0.87. What is the ratio of the Amount (in current US$) in Ethiopia in 2002 to that in 2003?
Your response must be concise. 2.61. What is the ratio of the Amount (in current US$) of Low income in 2002 to that in 2004?
Offer a terse response. 0.8. What is the ratio of the Amount (in current US$) in Burundi in 2002 to that in 2004?
Your response must be concise. 3.2. What is the ratio of the Amount (in current US$) in Ethiopia in 2002 to that in 2004?
Offer a very short reply. 2.14. What is the ratio of the Amount (in current US$) of Low income in 2002 to that in 2005?
Ensure brevity in your answer.  0.86. What is the ratio of the Amount (in current US$) in Burundi in 2002 to that in 2005?
Provide a short and direct response. 1.37. What is the ratio of the Amount (in current US$) in Ethiopia in 2002 to that in 2005?
Offer a terse response. 1.83. What is the ratio of the Amount (in current US$) in Burundi in 2002 to that in 2006?
Offer a very short reply. 0.99. What is the ratio of the Amount (in current US$) of Ethiopia in 2002 to that in 2006?
Your response must be concise. 2.2. What is the ratio of the Amount (in current US$) of Low income in 2003 to that in 2004?
Offer a terse response. 0.93. What is the ratio of the Amount (in current US$) in Burundi in 2003 to that in 2004?
Make the answer very short. 3.69. What is the ratio of the Amount (in current US$) of Ethiopia in 2003 to that in 2004?
Offer a very short reply. 0.82. What is the ratio of the Amount (in current US$) in Low income in 2003 to that in 2005?
Offer a very short reply. 0.99. What is the ratio of the Amount (in current US$) in Burundi in 2003 to that in 2005?
Your response must be concise. 1.58. What is the ratio of the Amount (in current US$) of Ethiopia in 2003 to that in 2005?
Provide a succinct answer. 0.7. What is the ratio of the Amount (in current US$) in Low income in 2003 to that in 2006?
Provide a succinct answer. 1.11. What is the ratio of the Amount (in current US$) in Burundi in 2003 to that in 2006?
Offer a very short reply. 1.15. What is the ratio of the Amount (in current US$) in Ethiopia in 2003 to that in 2006?
Give a very brief answer. 0.84. What is the ratio of the Amount (in current US$) in Low income in 2004 to that in 2005?
Provide a short and direct response. 1.06. What is the ratio of the Amount (in current US$) of Burundi in 2004 to that in 2005?
Give a very brief answer. 0.43. What is the ratio of the Amount (in current US$) in Ethiopia in 2004 to that in 2005?
Your answer should be compact. 0.85. What is the ratio of the Amount (in current US$) in Low income in 2004 to that in 2006?
Keep it short and to the point. 1.19. What is the ratio of the Amount (in current US$) of Burundi in 2004 to that in 2006?
Make the answer very short. 0.31. What is the ratio of the Amount (in current US$) of Ethiopia in 2004 to that in 2006?
Your answer should be compact. 1.03. What is the ratio of the Amount (in current US$) of Low income in 2005 to that in 2006?
Your answer should be compact. 1.12. What is the ratio of the Amount (in current US$) of Burundi in 2005 to that in 2006?
Offer a very short reply. 0.73. What is the ratio of the Amount (in current US$) in Ethiopia in 2005 to that in 2006?
Provide a short and direct response. 1.21. What is the ratio of the Amount (in current US$) of Morocco in 2005 to that in 2006?
Offer a terse response. 1.01. What is the difference between the highest and the second highest Amount (in current US$) of Low income?
Provide a succinct answer. 2.06e+08. What is the difference between the highest and the second highest Amount (in current US$) of Burundi?
Provide a short and direct response. 2.42e+06. What is the difference between the highest and the second highest Amount (in current US$) of Ethiopia?
Your answer should be very brief. 1.11e+08. What is the difference between the highest and the second highest Amount (in current US$) in Morocco?
Your answer should be very brief. 6.27e+06. What is the difference between the highest and the lowest Amount (in current US$) in Low income?
Make the answer very short. 1.49e+09. What is the difference between the highest and the lowest Amount (in current US$) of Burundi?
Keep it short and to the point. 2.89e+07. What is the difference between the highest and the lowest Amount (in current US$) of Ethiopia?
Your response must be concise. 4.40e+08. What is the difference between the highest and the lowest Amount (in current US$) in Morocco?
Ensure brevity in your answer.  4.45e+08. 